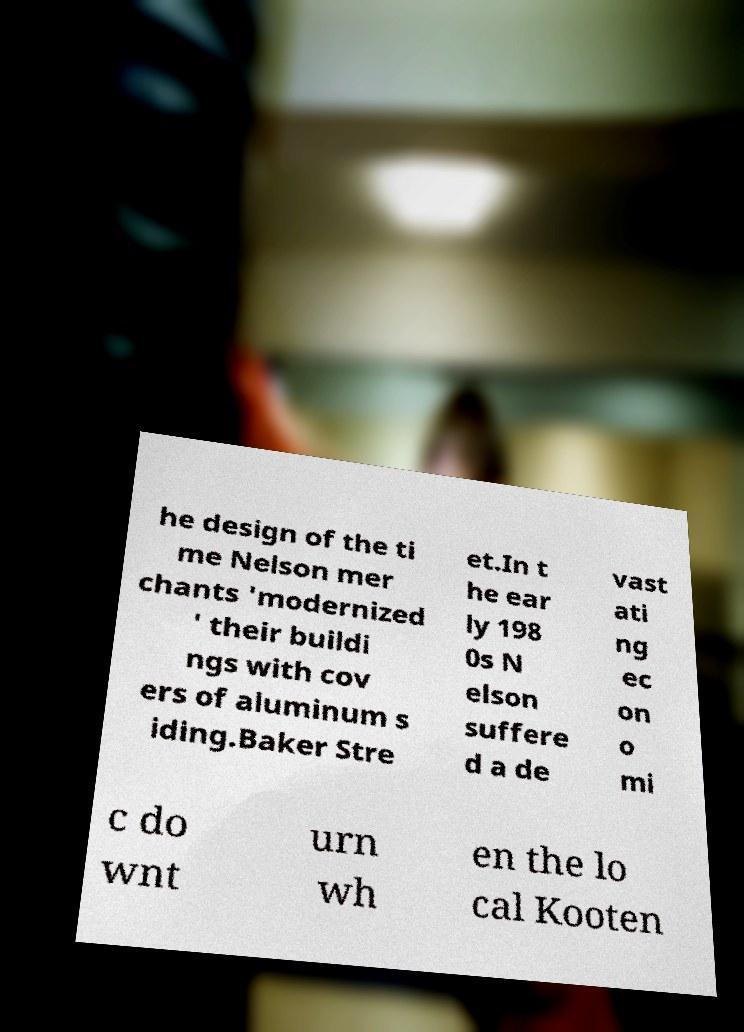Can you read and provide the text displayed in the image?This photo seems to have some interesting text. Can you extract and type it out for me? he design of the ti me Nelson mer chants 'modernized ' their buildi ngs with cov ers of aluminum s iding.Baker Stre et.In t he ear ly 198 0s N elson suffere d a de vast ati ng ec on o mi c do wnt urn wh en the lo cal Kooten 